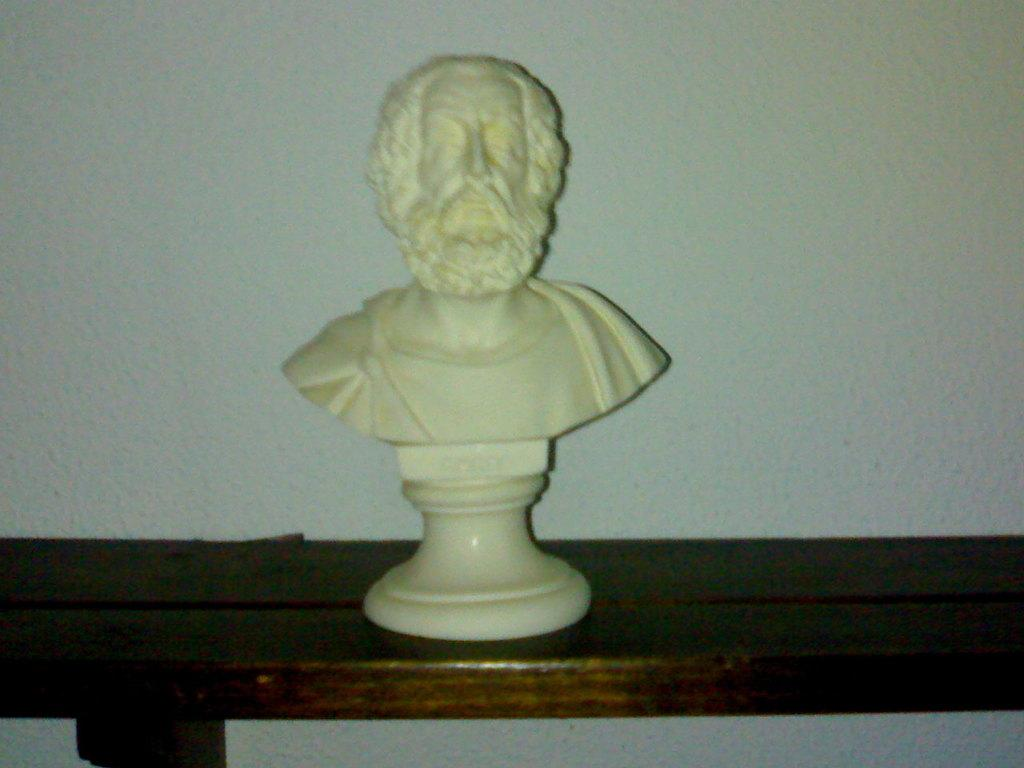What is the main subject of the image? There is a statue in the image. What material is the statue made of? The statue is made of white marble. Where is the statue located in the image? The statue is on a wooden table. How many girls are standing next to the statue in the image? There are no girls present in the image; it only features a statue on a wooden table. What type of cattle can be seen grazing near the statue in the image? There is no cattle present in the image; it only features a statue on a wooden table. 